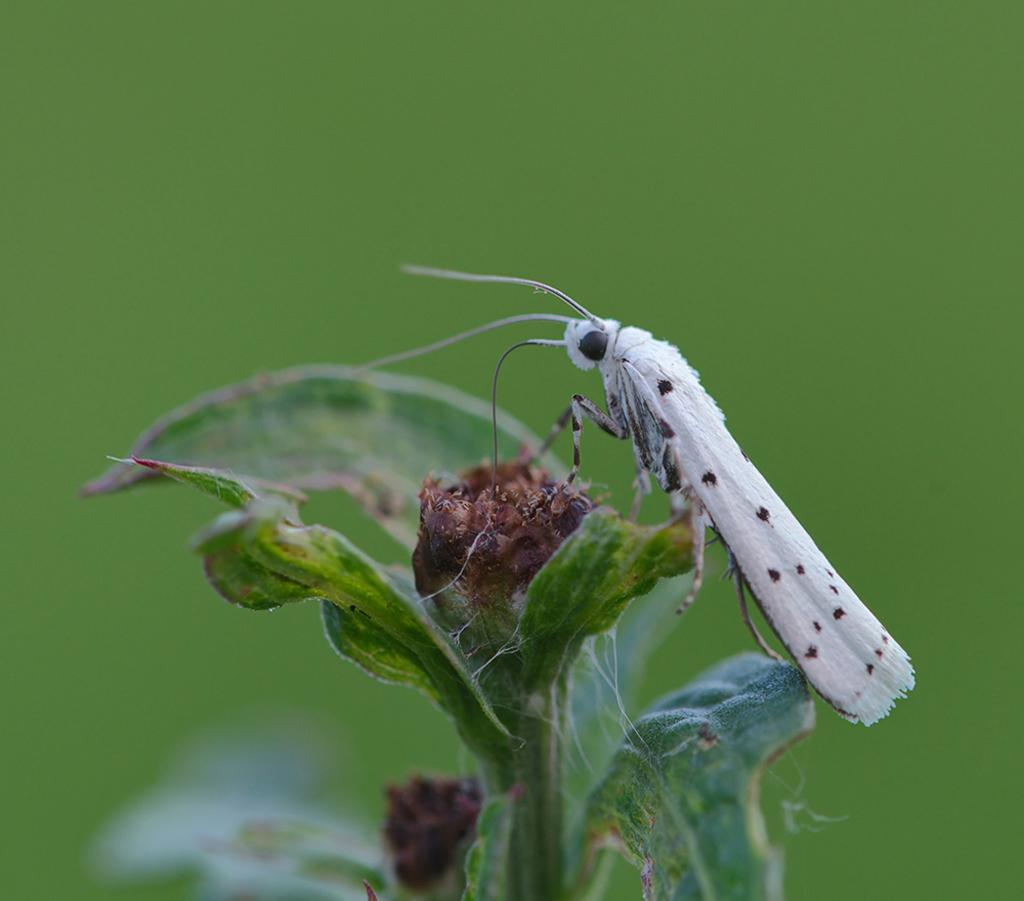What type of creature is in the image? There is an insect in the image. What colors can be seen on the insect? The insect is white and black in color. Where is the insect located in the image? The insect is sitting on a plant. What color is the background of the image? The background of the image is green in color. What type of edge is visible on the spade in the image? There is no spade present in the image, so there is no edge to describe. 